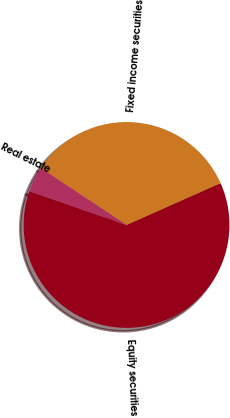Convert chart. <chart><loc_0><loc_0><loc_500><loc_500><pie_chart><fcel>Equity securities<fcel>Fixed income securities<fcel>Real estate<nl><fcel>62.0%<fcel>34.0%<fcel>4.0%<nl></chart> 